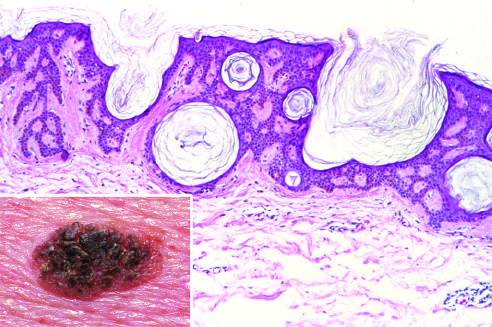does microscopic examination show an orderly proliferation of uniform, basaloid keratinocytes that tend to form keratin microcysts horn cysts?
Answer the question using a single word or phrase. Yes 